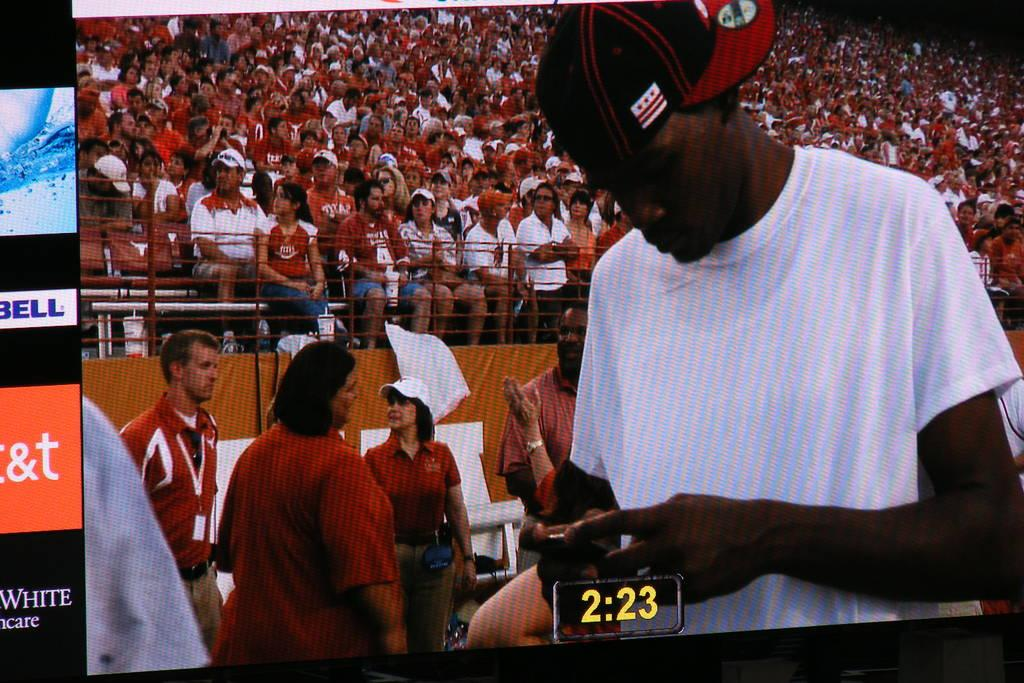<image>
Write a terse but informative summary of the picture. A timer at a ballgame reads 2:23 in yellow numbers. 